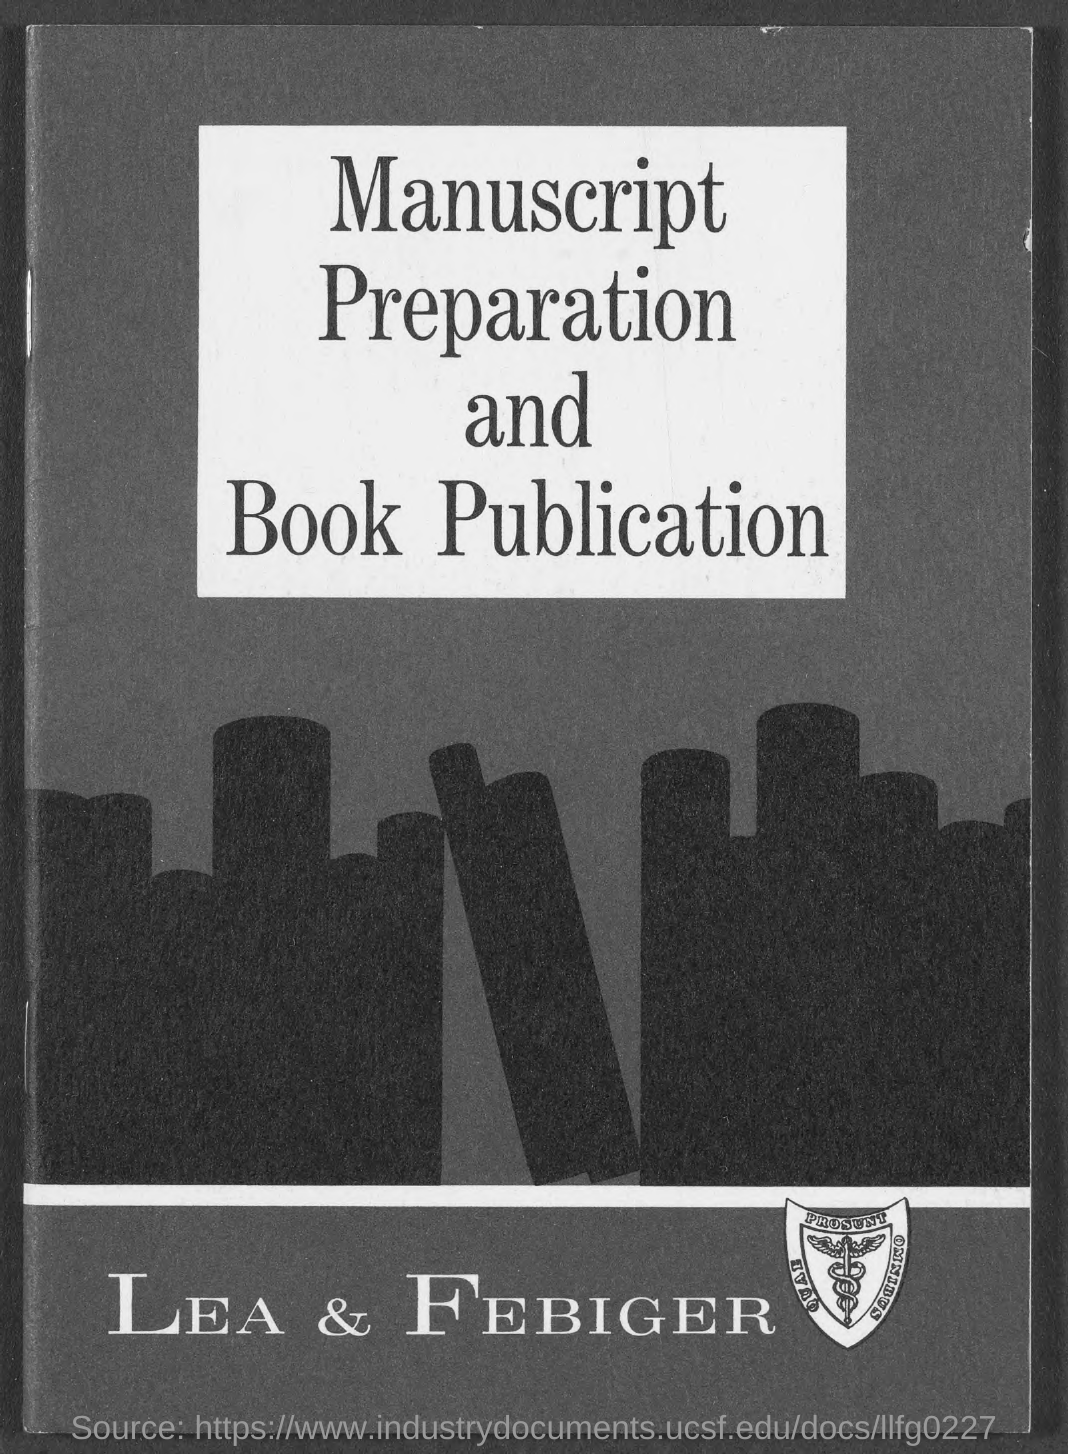Which book publisher is mentioned in the document?
Offer a very short reply. LEA & FEBIGER. 